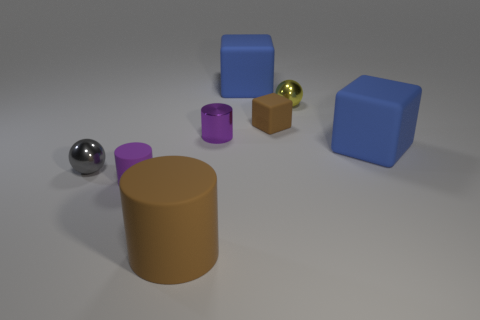Add 2 small cubes. How many objects exist? 10 Subtract all blocks. How many objects are left? 5 Subtract all small shiny cylinders. Subtract all tiny yellow objects. How many objects are left? 6 Add 5 brown cylinders. How many brown cylinders are left? 6 Add 2 gray shiny balls. How many gray shiny balls exist? 3 Subtract 2 blue cubes. How many objects are left? 6 